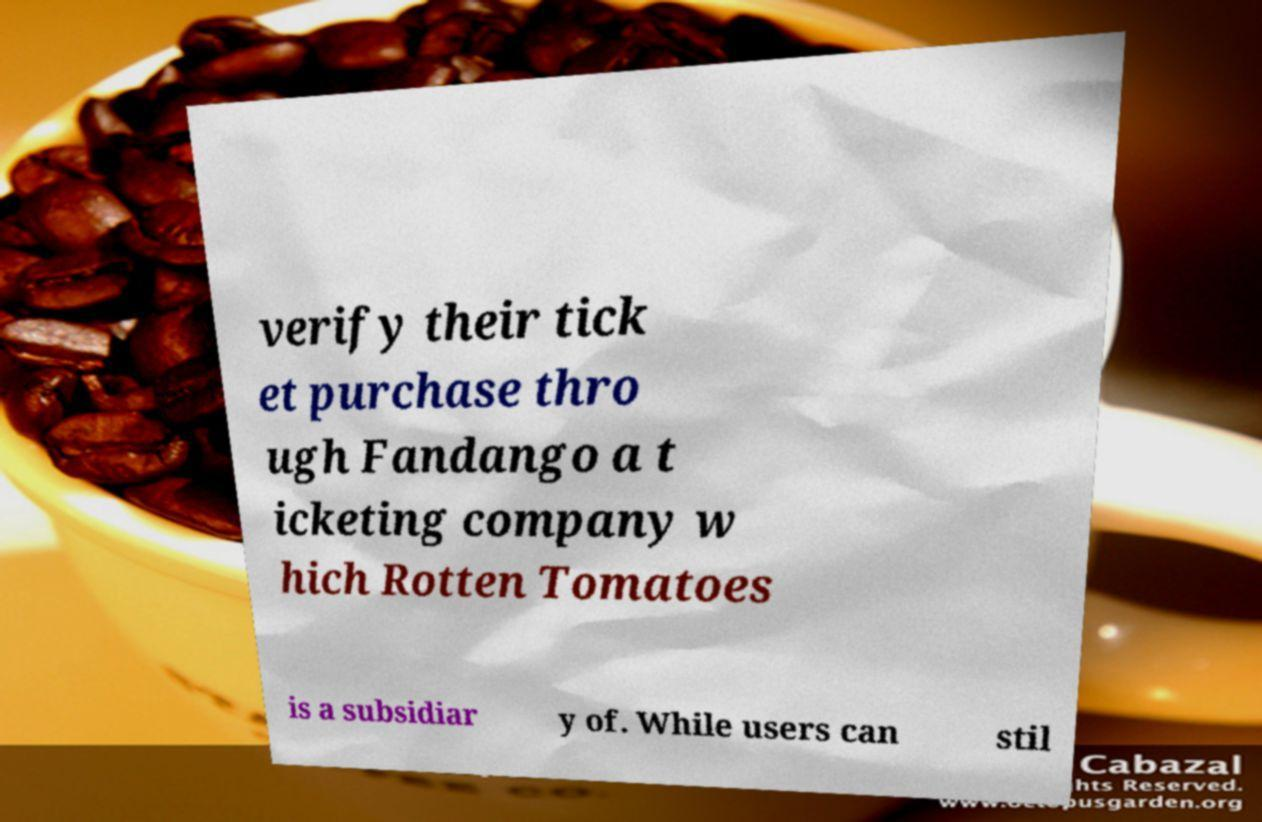I need the written content from this picture converted into text. Can you do that? verify their tick et purchase thro ugh Fandango a t icketing company w hich Rotten Tomatoes is a subsidiar y of. While users can stil 